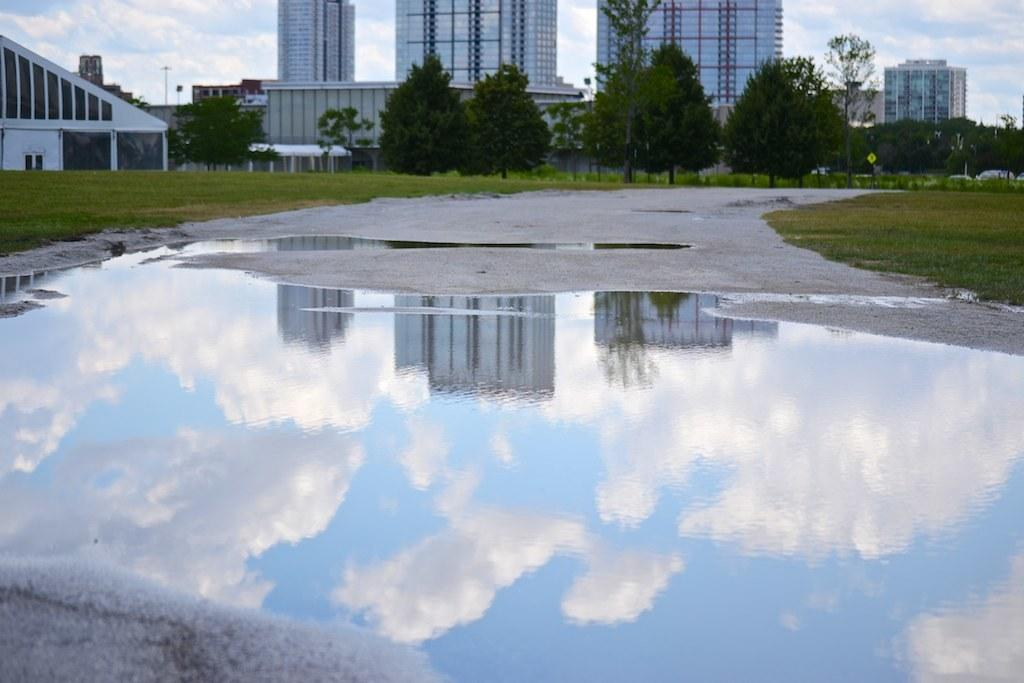What can be seen in the center of the image? There are buildings and trees in the center of the image. What is present on the road at the bottom of the image? There is water on the road at the bottom of the image. What part of the natural environment is visible in the image? The sky is visible in the background of the image. How many oranges are hanging from the trees in the image? There are no oranges present in the image; it features buildings and trees. What type of skirt is being worn by the building in the image? There is no skirt present in the image, as buildings do not wear clothing. 